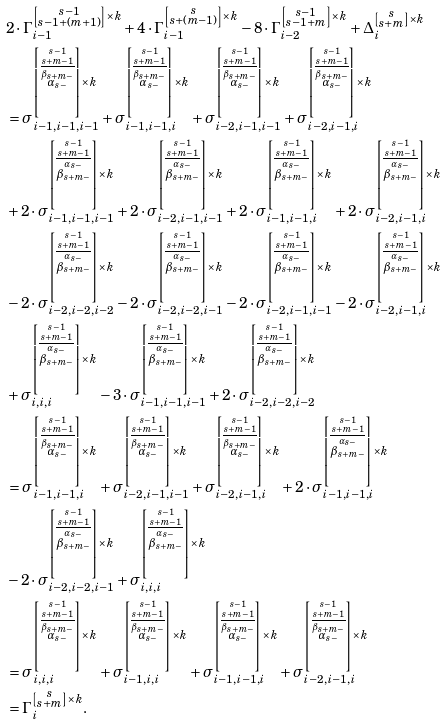Convert formula to latex. <formula><loc_0><loc_0><loc_500><loc_500>& 2 \cdot \Gamma _ { i - 1 } ^ { \left [ \substack { s - 1 \\ s - 1 + ( m + 1 ) } \right ] \times k } + 4 \cdot \Gamma _ { i - 1 } ^ { \left [ \substack { s \\ s + ( m - 1 ) } \right ] \times k } - 8 \cdot \Gamma _ { i - 2 } ^ { \left [ \substack { s - 1 \\ s - 1 + m } \right ] \times k } + \Delta _ { i } ^ { \left [ \substack { s \\ s + m } \right ] \times k } \\ & = \sigma _ { i - 1 , i - 1 , i - 1 } ^ { \left [ \stackrel { s - 1 } { \stackrel { s + m - 1 } { \overline { \stackrel { \beta _ { s + m - } } { \alpha _ { s - } } } } } \right ] \times k } + \sigma _ { i - 1 , i - 1 , i } ^ { \left [ \stackrel { s - 1 } { \stackrel { s + m - 1 } { \overline { \stackrel { \beta _ { s + m - } } { \alpha _ { s - } } } } } \right ] \times k } + \sigma _ { i - 2 , i - 1 , i - 1 } ^ { \left [ \stackrel { s - 1 } { \stackrel { s + m - 1 } { \overline { \stackrel { \beta _ { s + m - } } { \alpha _ { s - } } } } } \right ] \times k } + \sigma _ { i - 2 , i - 1 , i } ^ { \left [ \stackrel { s - 1 } { \stackrel { s + m - 1 } { \overline { \stackrel { \beta _ { s + m - } } { \alpha _ { s - } } } } } \right ] \times k } \\ & + 2 \cdot \sigma _ { i - 1 , i - 1 , i - 1 } ^ { \left [ \stackrel { s - 1 } { \stackrel { s + m - 1 } { \overline { \stackrel { \alpha _ { s - } } { \beta _ { s + m - } } } } } \right ] \times k } + 2 \cdot \sigma _ { i - 2 , i - 1 , i - 1 } ^ { \left [ \stackrel { s - 1 } { \stackrel { s + m - 1 } { \overline { \stackrel { \alpha _ { s - } } { \beta _ { s + m - } } } } } \right ] \times k } + 2 \cdot \sigma _ { i - 1 , i - 1 , i } ^ { \left [ \stackrel { s - 1 } { \stackrel { s + m - 1 } { \overline { \stackrel { \alpha _ { s - } } { \beta _ { s + m - } } } } } \right ] \times k } + 2 \cdot \sigma _ { i - 2 , i - 1 , i } ^ { \left [ \stackrel { s - 1 } { \stackrel { s + m - 1 } { \overline { \stackrel { \alpha _ { s - } } { \beta _ { s + m - } } } } } \right ] \times k } \\ & - 2 \cdot \sigma _ { i - 2 , i - 2 , i - 2 } ^ { \left [ \stackrel { s - 1 } { \stackrel { s + m - 1 } { \overline { \stackrel { \alpha _ { s - } } { \beta _ { s + m - } } } } } \right ] \times k } - 2 \cdot \sigma _ { i - 2 , i - 2 , i - 1 } ^ { \left [ \stackrel { s - 1 } { \stackrel { s + m - 1 } { \overline { \stackrel { \alpha _ { s - } } { \beta _ { s + m - } } } } } \right ] \times k } - 2 \cdot \sigma _ { i - 2 , i - 1 , i - 1 } ^ { \left [ \stackrel { s - 1 } { \stackrel { s + m - 1 } { \overline { \stackrel { \alpha _ { s - } } { \beta _ { s + m - } } } } } \right ] \times k } - 2 \cdot \sigma _ { i - 2 , i - 1 , i } ^ { \left [ \stackrel { s - 1 } { \stackrel { s + m - 1 } { \overline { \stackrel { \alpha _ { s - } } { \beta _ { s + m - } } } } } \right ] \times k } \\ & + \sigma _ { i , i , i } ^ { \left [ \stackrel { s - 1 } { \stackrel { s + m - 1 } { \overline { \stackrel { \alpha _ { s - } } { \beta _ { s + m - } } } } } \right ] \times k } - 3 \cdot \sigma _ { i - 1 , i - 1 , i - 1 } ^ { \left [ \stackrel { s - 1 } { \stackrel { s + m - 1 } { \overline { \stackrel { \alpha _ { s - } } { \beta _ { s + m - } } } } } \right ] \times k } + 2 \cdot \sigma _ { i - 2 , i - 2 , i - 2 } ^ { \left [ \stackrel { s - 1 } { \stackrel { s + m - 1 } { \overline { \stackrel { \alpha _ { s - } } { \beta _ { s + m - } } } } } \right ] \times k } \\ & = \sigma _ { i - 1 , i - 1 , i } ^ { \left [ \stackrel { s - 1 } { \stackrel { s + m - 1 } { \overline { \stackrel { \beta _ { s + m - } } { \alpha _ { s - } } } } } \right ] \times k } + \sigma _ { i - 2 , i - 1 , i - 1 } ^ { \left [ \stackrel { s - 1 } { \stackrel { s + m - 1 } { \overline { \stackrel { \beta _ { s + m - } } { \alpha _ { s - } } } } } \right ] \times k } + \sigma _ { i - 2 , i - 1 , i } ^ { \left [ \stackrel { s - 1 } { \stackrel { s + m - 1 } { \overline { \stackrel { \beta _ { s + m - } } { \alpha _ { s - } } } } } \right ] \times k } + 2 \cdot \sigma _ { i - 1 , i - 1 , i } ^ { \left [ \stackrel { s - 1 } { \stackrel { s + m - 1 } { \overline { \stackrel { \alpha _ { s - } } { \beta _ { s + m - } } } } } \right ] \times k } \\ & - 2 \cdot \sigma _ { i - 2 , i - 2 , i - 1 } ^ { \left [ \stackrel { s - 1 } { \stackrel { s + m - 1 } { \overline { \stackrel { \alpha _ { s - } } { \beta _ { s + m - } } } } } \right ] \times k } + \sigma _ { i , i , i } ^ { \left [ \stackrel { s - 1 } { \stackrel { s + m - 1 } { \overline { \stackrel { \alpha _ { s - } } { \beta _ { s + m - } } } } } \right ] \times k } \\ & = \sigma _ { i , i , i } ^ { \left [ \stackrel { s - 1 } { \stackrel { s + m - 1 } { \overline { \stackrel { \beta _ { s + m - } } { \alpha _ { s - } } } } } \right ] \times k } + \sigma _ { i - 1 , i , i } ^ { \left [ \stackrel { s - 1 } { \stackrel { s + m - 1 } { \overline { \stackrel { \beta _ { s + m - } } { \alpha _ { s - } } } } } \right ] \times k } + \sigma _ { i - 1 , i - 1 , i } ^ { \left [ \stackrel { s - 1 } { \stackrel { s + m - 1 } { \overline { \stackrel { \beta _ { s + m - } } { \alpha _ { s - } } } } } \right ] \times k } + \sigma _ { i - 2 , i - 1 , i } ^ { \left [ \stackrel { s - 1 } { \stackrel { s + m - 1 } { \overline { \stackrel { \beta _ { s + m - } } { \alpha _ { s - } } } } } \right ] \times k } \\ & = \Gamma _ { i } ^ { \left [ \substack { s \\ s + m } \right ] \times k } .</formula> 